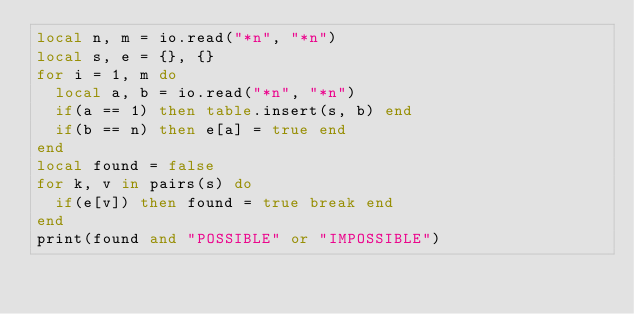Convert code to text. <code><loc_0><loc_0><loc_500><loc_500><_Lua_>local n, m = io.read("*n", "*n")
local s, e = {}, {}
for i = 1, m do
  local a, b = io.read("*n", "*n")
  if(a == 1) then table.insert(s, b) end
  if(b == n) then e[a] = true end
end
local found = false
for k, v in pairs(s) do
  if(e[v]) then found = true break end
end
print(found and "POSSIBLE" or "IMPOSSIBLE")
</code> 